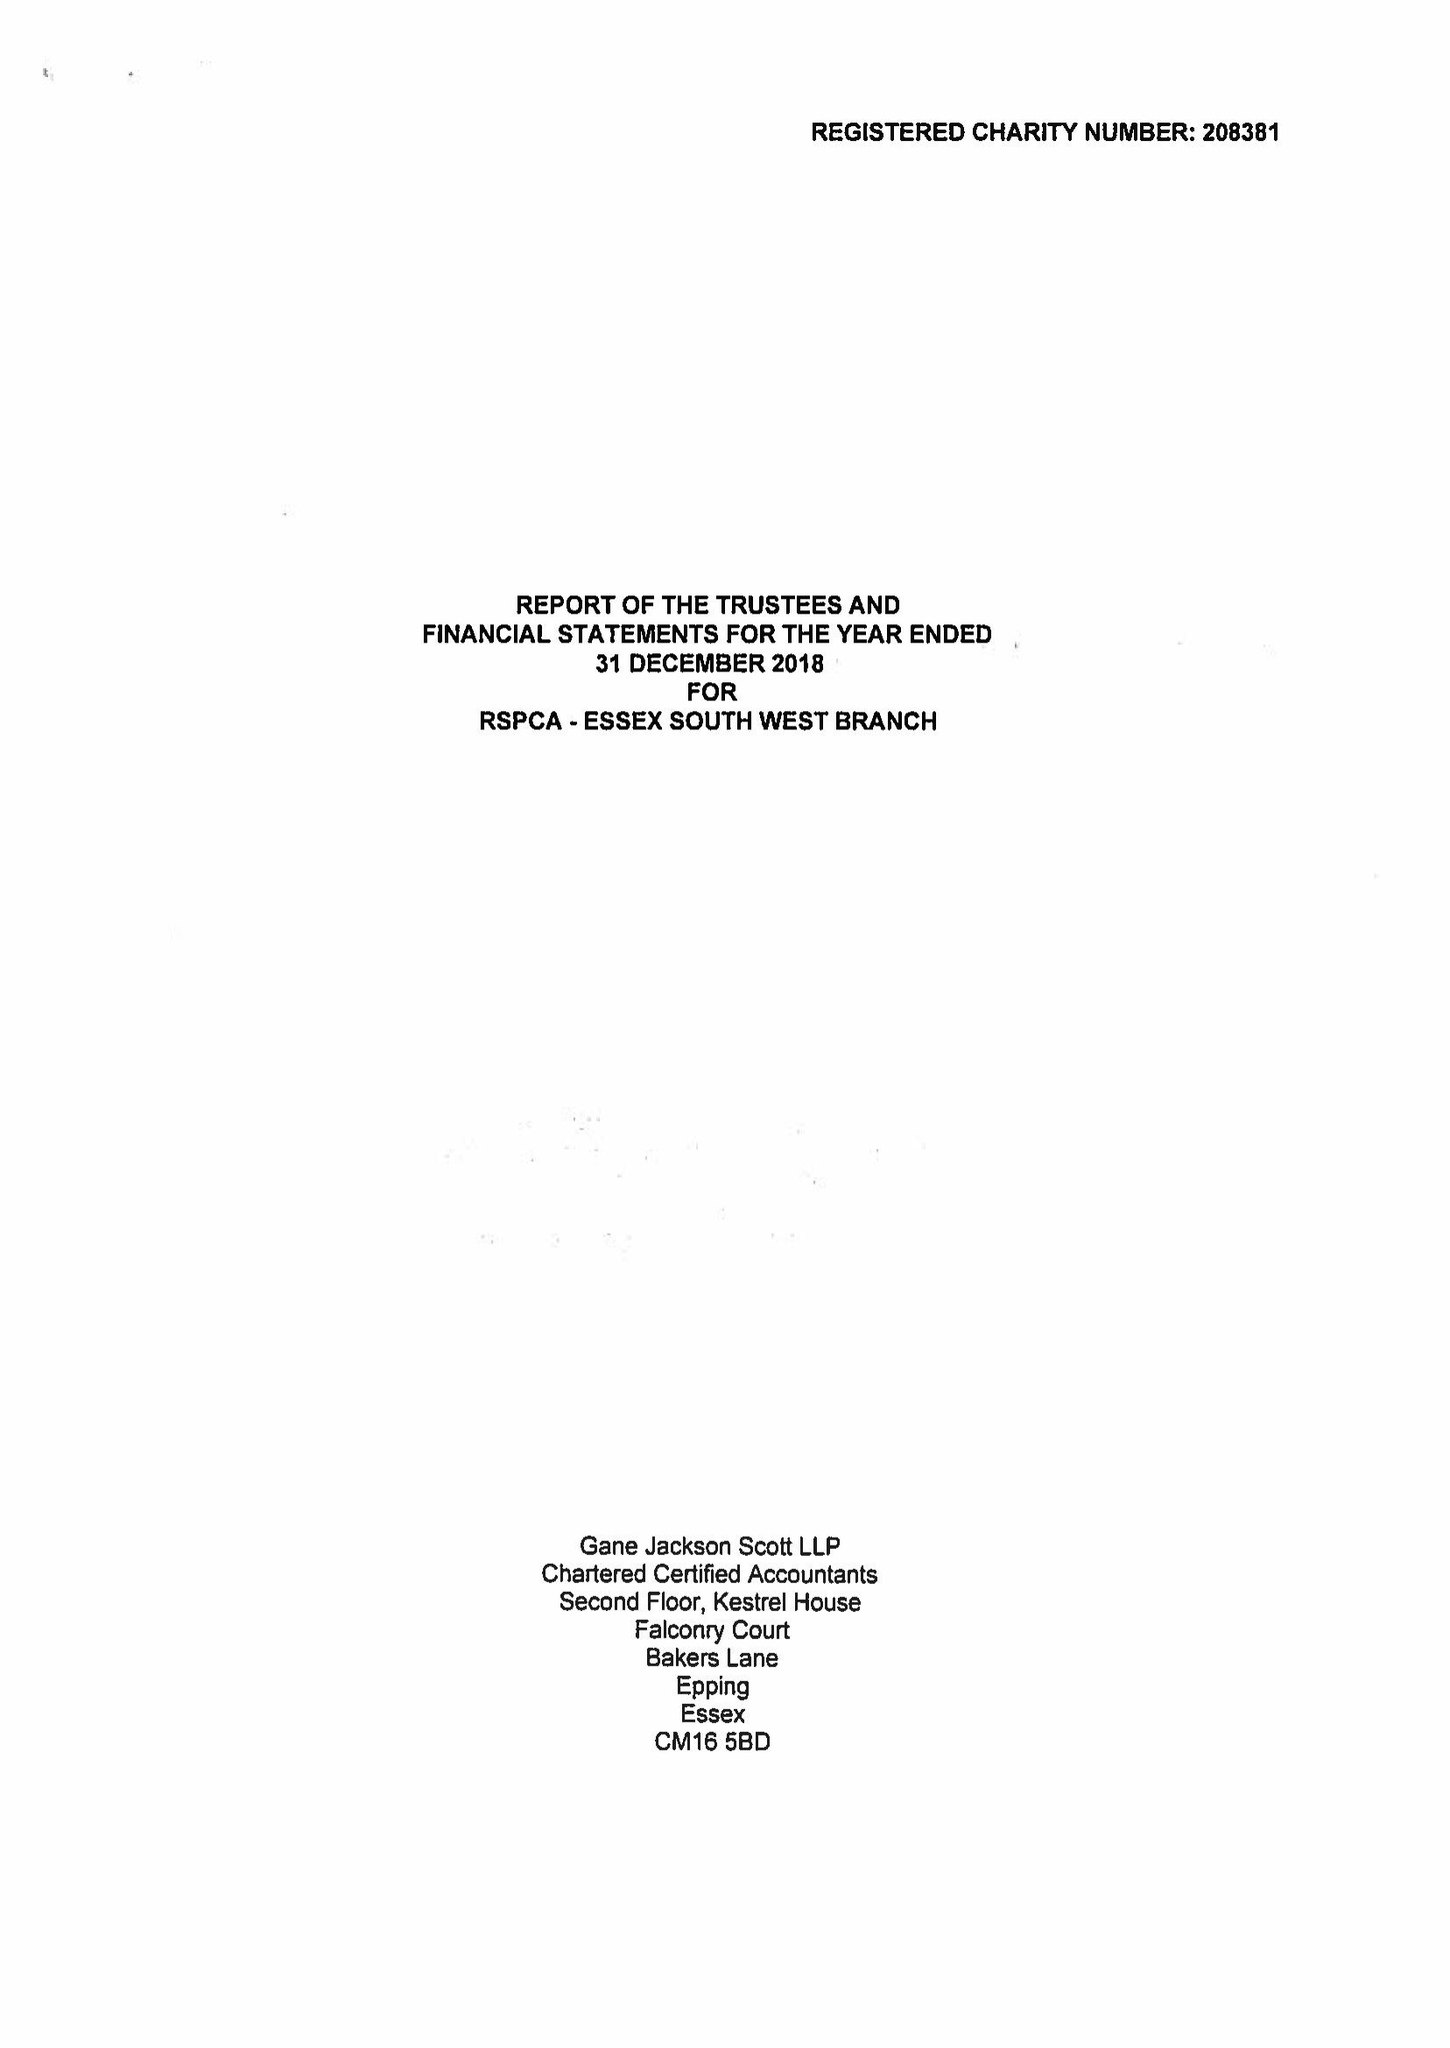What is the value for the report_date?
Answer the question using a single word or phrase. 2018-12-31 